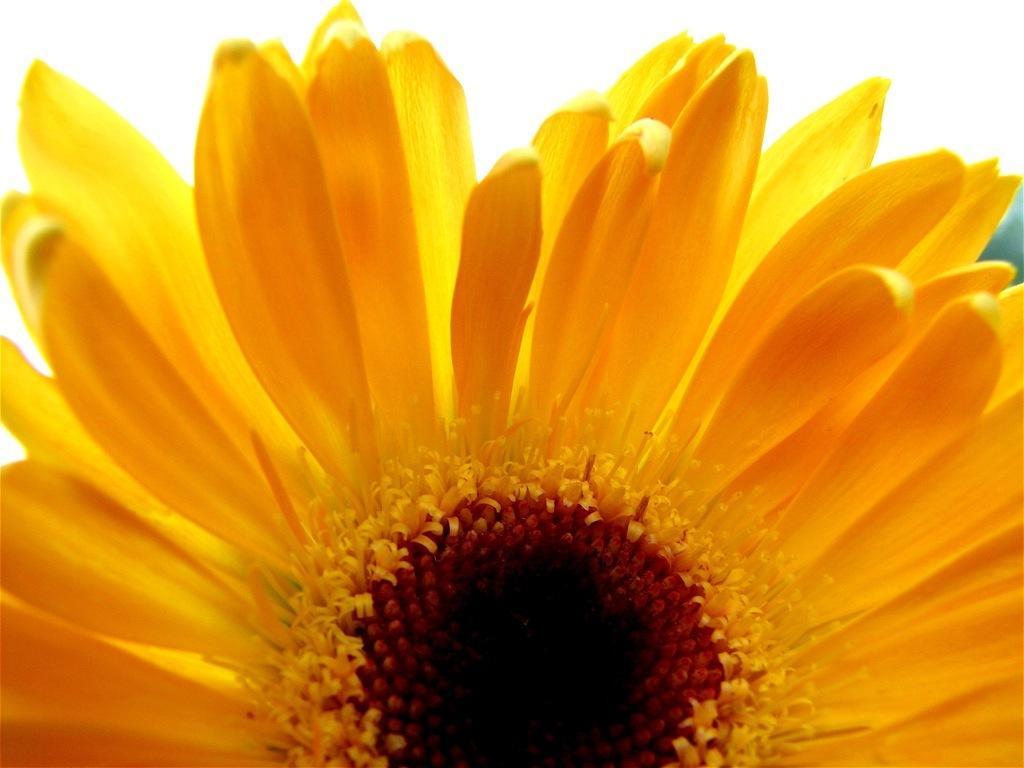Can you describe this image briefly? In the picture we can see sunflower. 